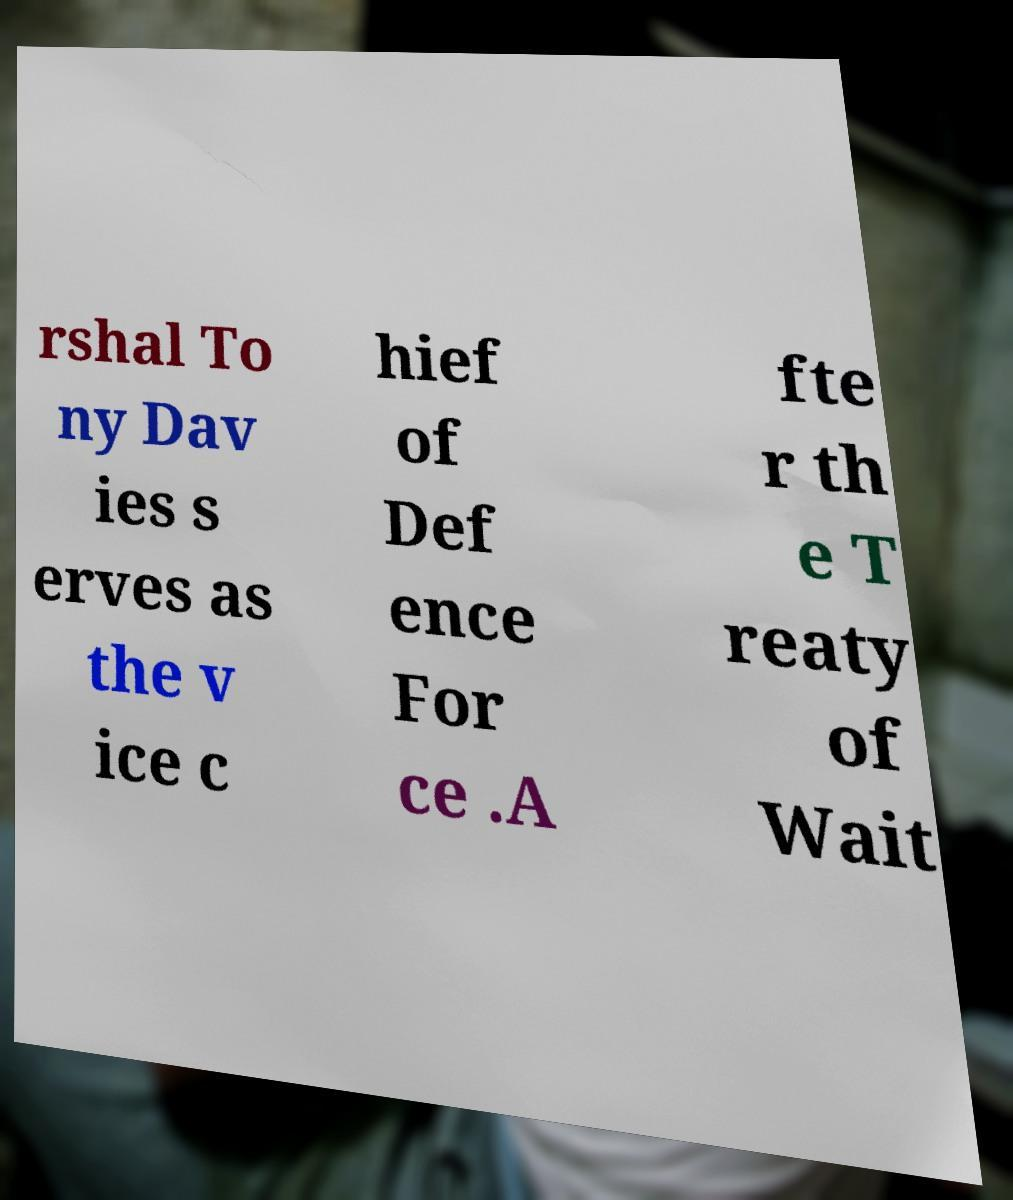I need the written content from this picture converted into text. Can you do that? rshal To ny Dav ies s erves as the v ice c hief of Def ence For ce .A fte r th e T reaty of Wait 